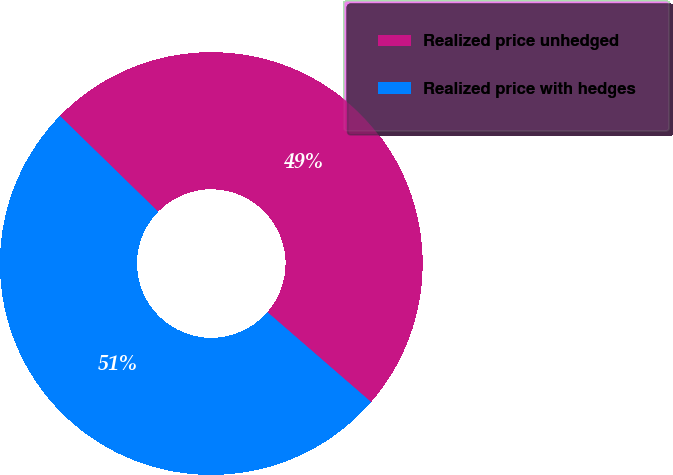<chart> <loc_0><loc_0><loc_500><loc_500><pie_chart><fcel>Realized price unhedged<fcel>Realized price with hedges<nl><fcel>49.07%<fcel>50.93%<nl></chart> 